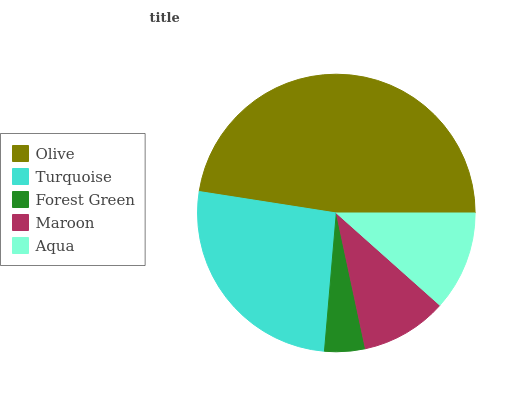Is Forest Green the minimum?
Answer yes or no. Yes. Is Olive the maximum?
Answer yes or no. Yes. Is Turquoise the minimum?
Answer yes or no. No. Is Turquoise the maximum?
Answer yes or no. No. Is Olive greater than Turquoise?
Answer yes or no. Yes. Is Turquoise less than Olive?
Answer yes or no. Yes. Is Turquoise greater than Olive?
Answer yes or no. No. Is Olive less than Turquoise?
Answer yes or no. No. Is Aqua the high median?
Answer yes or no. Yes. Is Aqua the low median?
Answer yes or no. Yes. Is Forest Green the high median?
Answer yes or no. No. Is Maroon the low median?
Answer yes or no. No. 